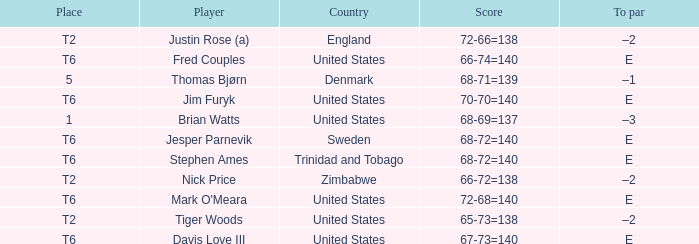The player for which country had a score of 66-72=138? Zimbabwe. 